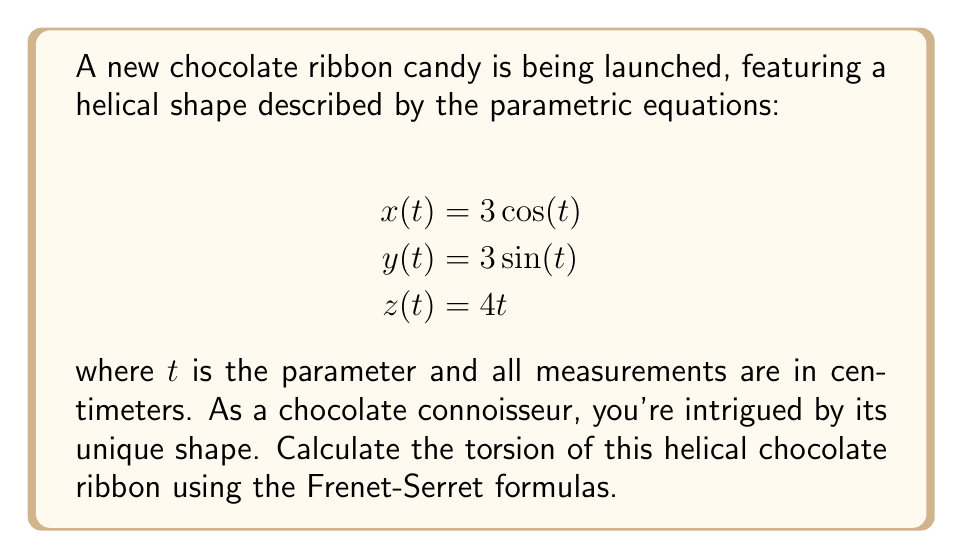Solve this math problem. To calculate the torsion of the helical chocolate ribbon, we'll use the Frenet-Serret formulas. Let's proceed step-by-step:

1) First, we need to find $\mathbf{r}(t)$, $\mathbf{r}'(t)$, $\mathbf{r}''(t)$, and $\mathbf{r}'''(t)$:

   $\mathbf{r}(t) = (3\cos(t), 3\sin(t), 4t)$
   $\mathbf{r}'(t) = (-3\sin(t), 3\cos(t), 4)$
   $\mathbf{r}''(t) = (-3\cos(t), -3\sin(t), 0)$
   $\mathbf{r}'''(t) = (3\sin(t), -3\cos(t), 0)$

2) The torsion $\tau$ is given by the formula:

   $$\tau = \frac{(\mathbf{r}'(t) \times \mathbf{r}''(t)) \cdot \mathbf{r}'''(t)}{|\mathbf{r}'(t) \times \mathbf{r}''(t)|^2}$$

3) Let's calculate $\mathbf{r}'(t) \times \mathbf{r}''(t)$:

   $\mathbf{r}'(t) \times \mathbf{r}''(t) = \begin{vmatrix} 
   \mathbf{i} & \mathbf{j} & \mathbf{k} \\
   -3\sin(t) & 3\cos(t) & 4 \\
   -3\cos(t) & -3\sin(t) & 0
   \end{vmatrix}$

   $= (-12\sin(t), -12\cos(t), -9\sin^2(t) - 9\cos^2(t))$
   $= (-12\sin(t), -12\cos(t), -9)$

4) Now, let's calculate $(\mathbf{r}'(t) \times \mathbf{r}''(t)) \cdot \mathbf{r}'''(t)$:

   $(-12\sin(t), -12\cos(t), -9) \cdot (3\sin(t), -3\cos(t), 0)$
   $= -36\sin^2(t) + 36\cos^2(t) = 36(\cos^2(t) - \sin^2(t)) = 36\cos(2t)$

5) Next, we need to calculate $|\mathbf{r}'(t) \times \mathbf{r}''(t)|^2$:

   $|-12\sin(t)|^2 + |-12\cos(t)|^2 + |-9|^2 = 144\sin^2(t) + 144\cos^2(t) + 81$
   $= 144(\sin^2(t) + \cos^2(t)) + 81 = 144 + 81 = 225$

6) Finally, we can calculate the torsion:

   $$\tau = \frac{36\cos(2t)}{225} = \frac{12\cos(2t)}{75}$$

This is a constant value, independent of $t$.
Answer: $\frac{12}{75} = \frac{4}{25}$ cm$^{-1}$ 